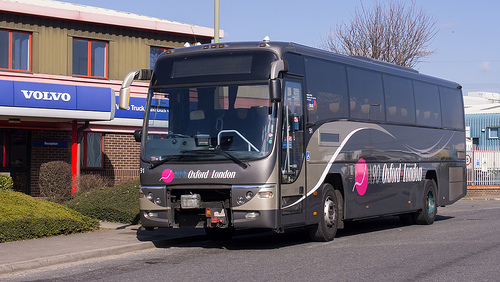Please provide a short description for this region: [0.3, 0.39, 0.54, 0.52]. This describes the front windshield of a bus, showcasing a broad, slightly tinted glass pane through which the vehicle's dashboard is partly visible. 